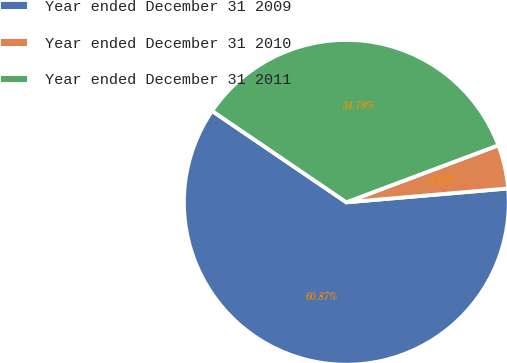Convert chart to OTSL. <chart><loc_0><loc_0><loc_500><loc_500><pie_chart><fcel>Year ended December 31 2009<fcel>Year ended December 31 2010<fcel>Year ended December 31 2011<nl><fcel>60.87%<fcel>4.35%<fcel>34.78%<nl></chart> 